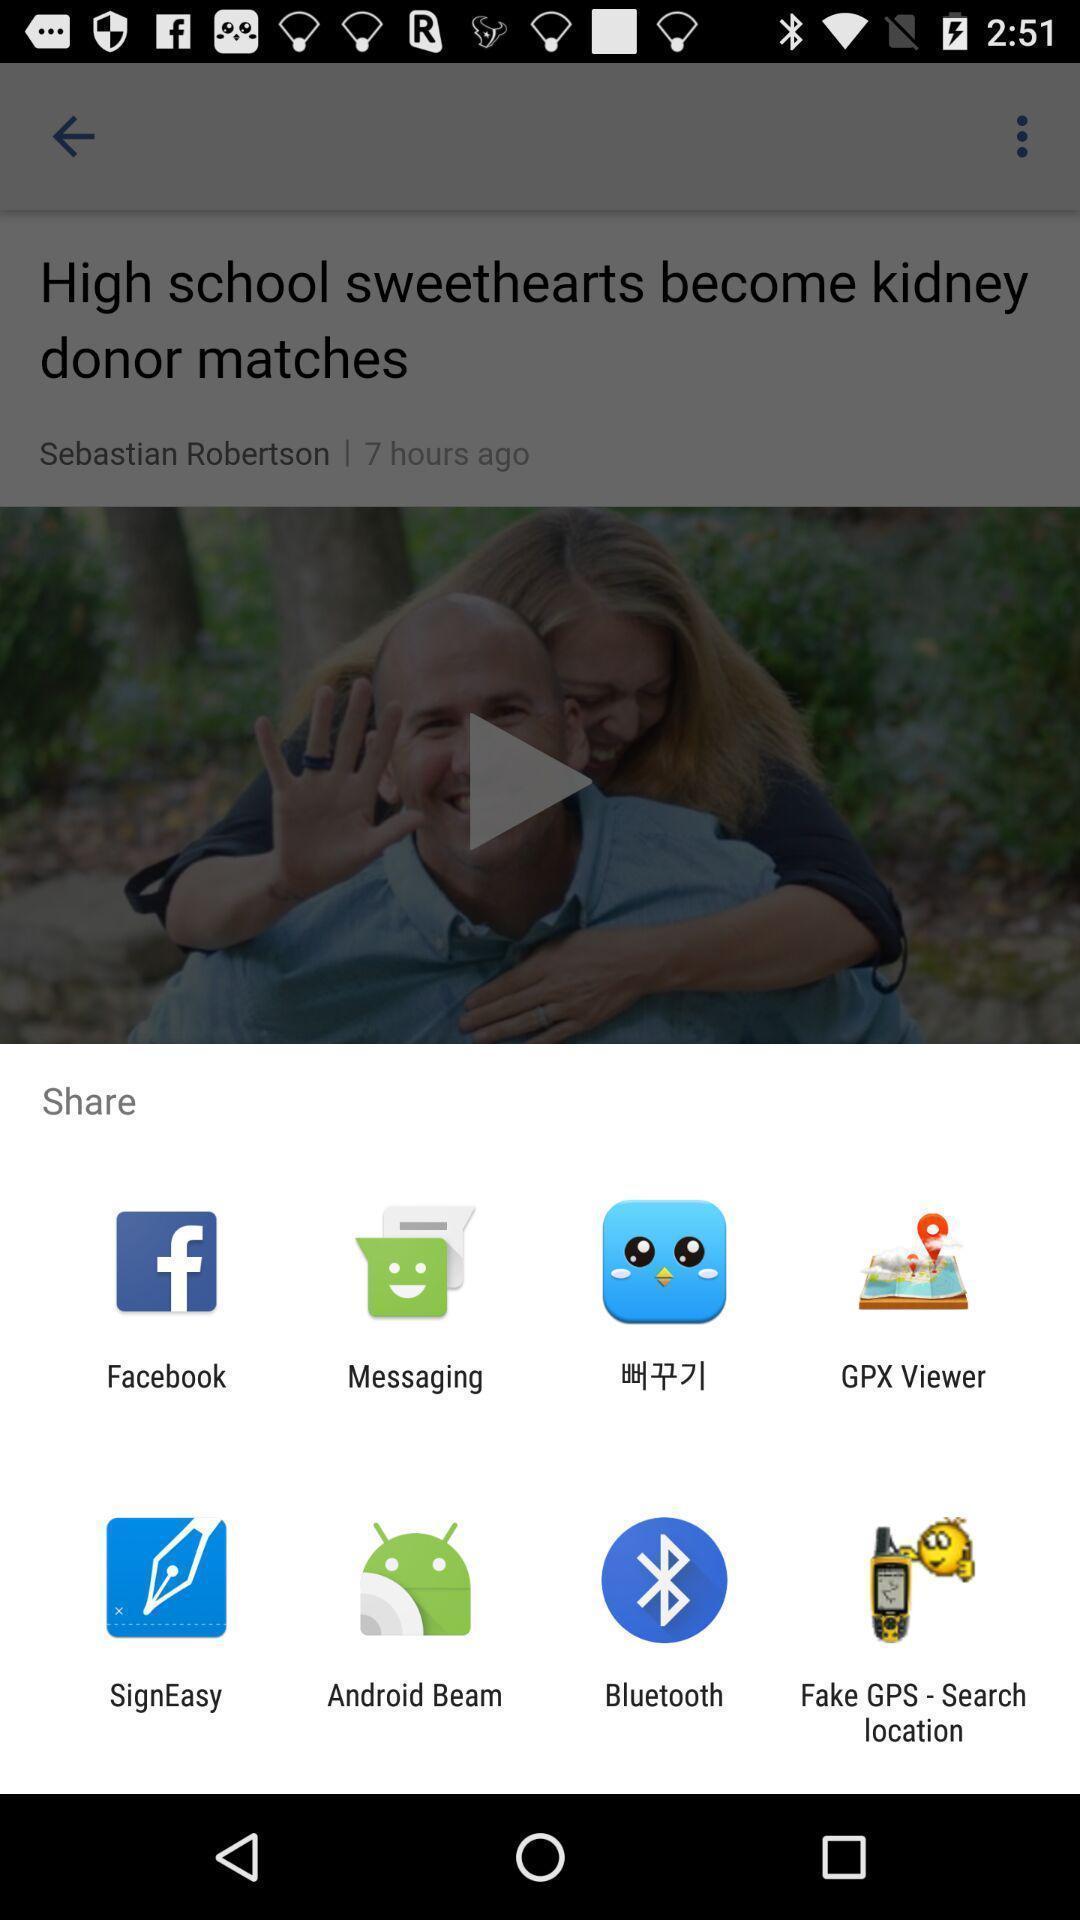Provide a textual representation of this image. Pop-up widget displaying sharing apps. 